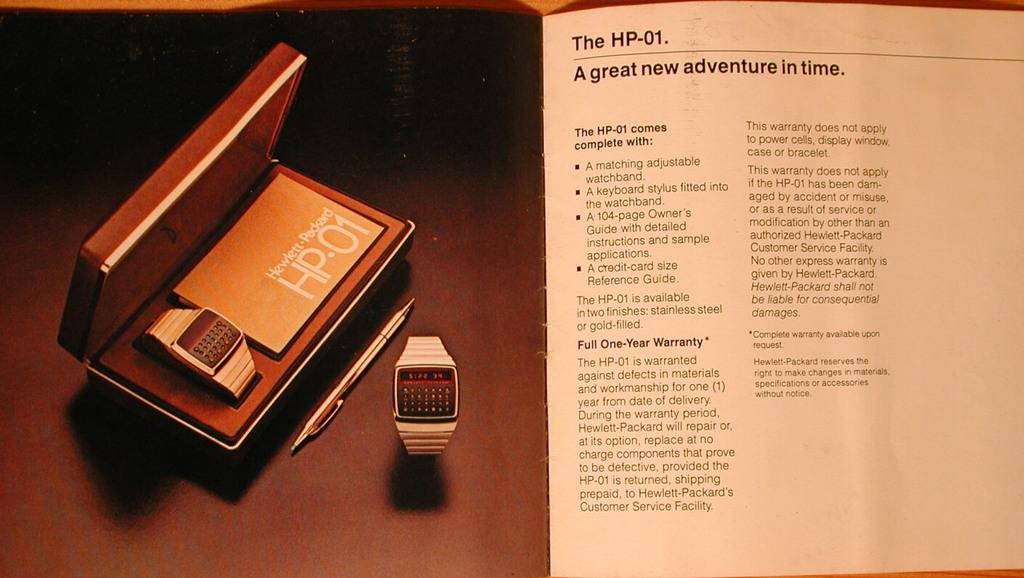<image>
Provide a brief description of the given image. A fancy electronic watch and manual for it reading the HP01 